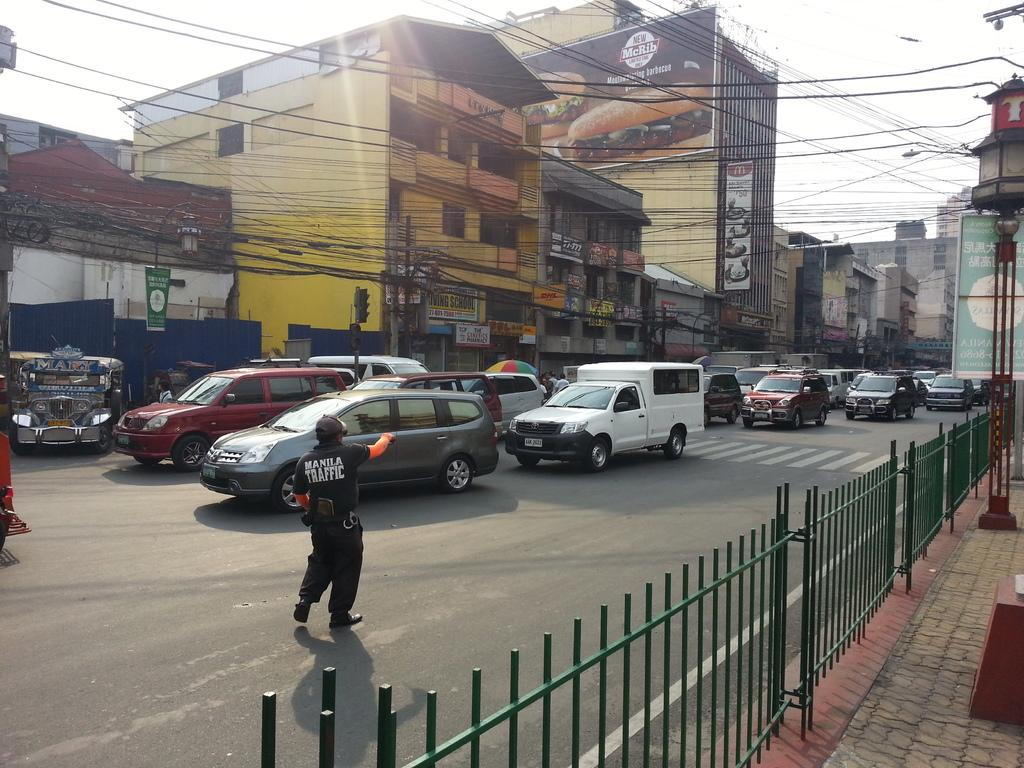What type of structures can be seen in the image? There are buildings in the image. What else can be seen moving in the image? There are vehicles in the image. What objects are emitting light in the image? There are lights in the image. What are the vertical structures in the image used for? There are poles in the image, which are likely used for supporting wires or signs. What are the flat, rectangular objects in the image used for? There are boards in the image, which could be used for advertising or displaying information. Can you identify any living beings in the image? Yes, there are people in the image. What other objects can be seen in the image that are related to the poles? There are wires in the image, which are likely strung between the poles. What type of barrier can be seen in the image? There is a fence in the image. What can be seen in the background of the image? The sky is visible in the background of the image. What type of design can be seen on the roots of the trees in the image? There are no trees or roots present in the image. What time of day is it in the image, based on the hour? The provided facts do not mention the time, so we cannot determine the hour in the image. 